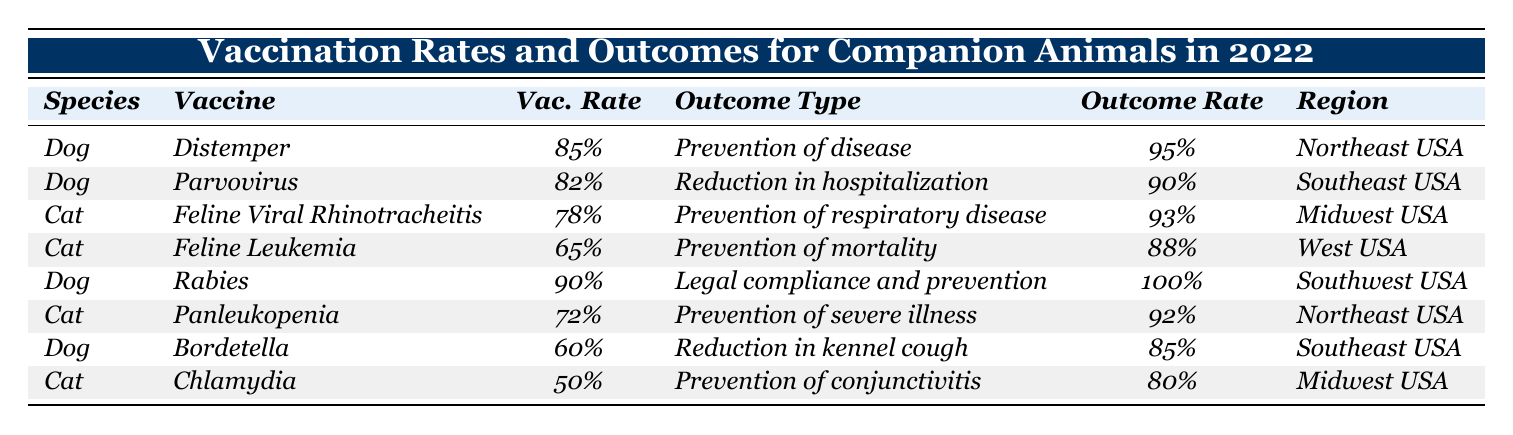What is the vaccination rate for dogs vaccinated against Distemper? The table shows that the vaccination rate for dogs vaccinated against Distemper is listed directly under the "Vac. Rate" column for that vaccine. It states 85%.
Answer: 85% Which vaccine for cats has the highest outcome rate? By examining the "Outcome Rate" for each cat vaccine in the table, Feline Viral Rhinotracheitis has an outcome rate of 93%, which is higher than the other cat vaccines listed.
Answer: Feline Viral Rhinotracheitis What is the average vaccination rate for dogs? The vaccination rates for dogs in the table are 85%, 82%, 90%, and 60%. To find the average, we first sum these values as percentages (85 + 82 + 90 + 60 = 317), then divide by the number of data points (4). Thus, the average is 317/4 = 79.25%.
Answer: 79.25% Is the outcome rate for Feline Leukemia sufficient for prevention of mortality? According to the table, the outcome rate for Feline Leukemia vaccination is 88%. This figure indicates that it is a high rate and generally accepted as sufficient for prevention of mortality.
Answer: Yes How many vaccines have an outcome rate of 90% or higher? We will review the "Outcome Rate" column to count the number of vaccines that meet or exceed the 90% threshold. The vaccines that qualify based on the table are Distemper (95%), Parvovirus (90%), Rabies (100%), and Feline Viral Rhinotracheitis (93%). This sums to four vaccines.
Answer: 4 What region has the lowest vaccination rate among the vaccines listed? To determine the region with the lowest vaccination rate, we compare all vaccination rates across regions. The Panleukopenia vaccination for cats has the lowest rate at 72%, which is the lowest figure displayed in the table.
Answer: Northeast USA If a dog is vaccinated against Rabies, what is the expected outcome in terms of prevention? The table indicates that the outcome for dogs vaccinated against Rabies is 100% expected prevention, meaning they are fully protected based on the data provided.
Answer: 100% Are dogs more likely to be vaccinated against Distemper than Bordetella? By comparing the vaccination rates for these two vaccines, Distemper has a rate of 85% while Bordetella has a rate of 60%, thus indicating that dogs are more likely vaccinated against Distemper.
Answer: Yes 